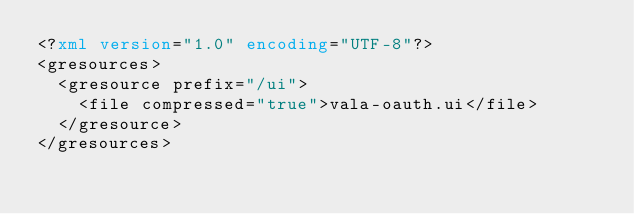Convert code to text. <code><loc_0><loc_0><loc_500><loc_500><_XML_><?xml version="1.0" encoding="UTF-8"?>
<gresources>
  <gresource prefix="/ui">
    <file compressed="true">vala-oauth.ui</file>
  </gresource>
</gresources>
</code> 